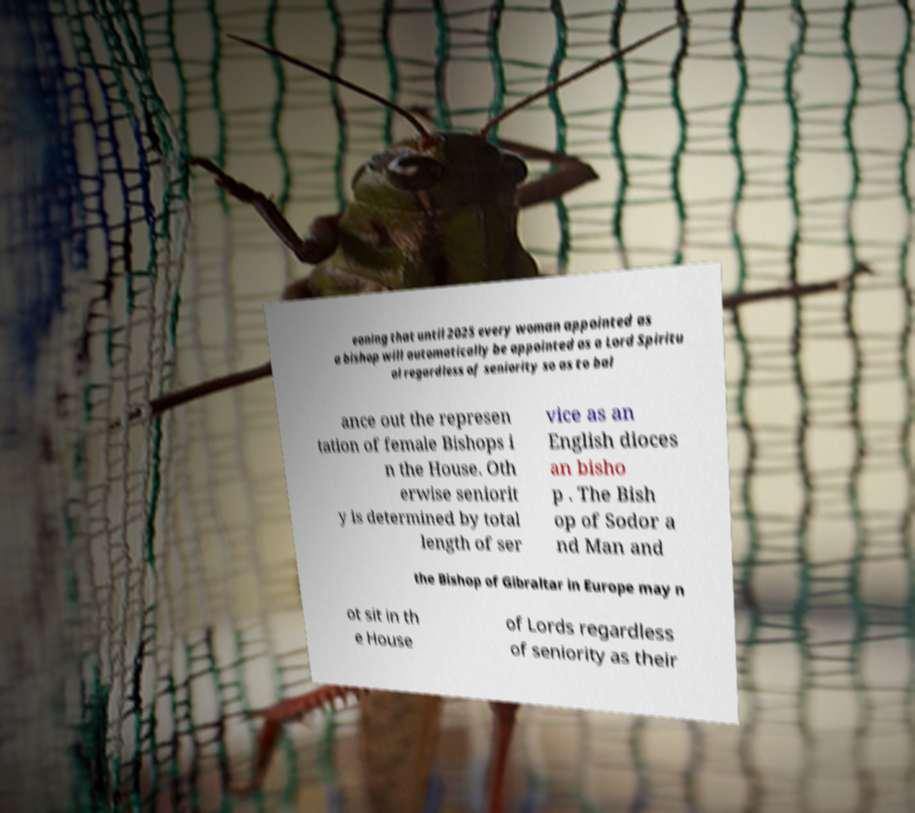Please identify and transcribe the text found in this image. eaning that until 2025 every woman appointed as a bishop will automatically be appointed as a Lord Spiritu al regardless of seniority so as to bal ance out the represen tation of female Bishops i n the House. Oth erwise seniorit y is determined by total length of ser vice as an English dioces an bisho p . The Bish op of Sodor a nd Man and the Bishop of Gibraltar in Europe may n ot sit in th e House of Lords regardless of seniority as their 